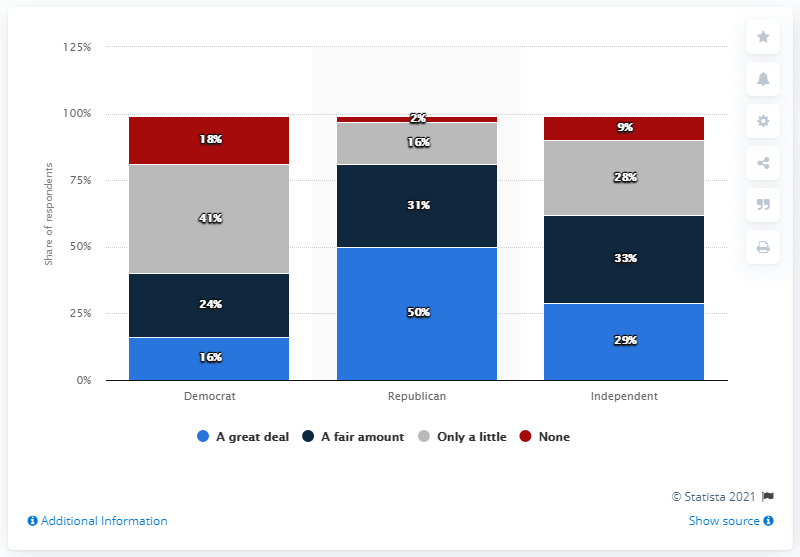Indicate a few pertinent items in this graphic. What is the least value of the color "red" that can be represented using at least 2 bits? The highest percentage in a great deal is 50%. 